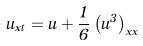Convert formula to latex. <formula><loc_0><loc_0><loc_500><loc_500>u _ { x t } = u + \frac { 1 } { 6 } \left ( u ^ { 3 } \right ) _ { x x }</formula> 